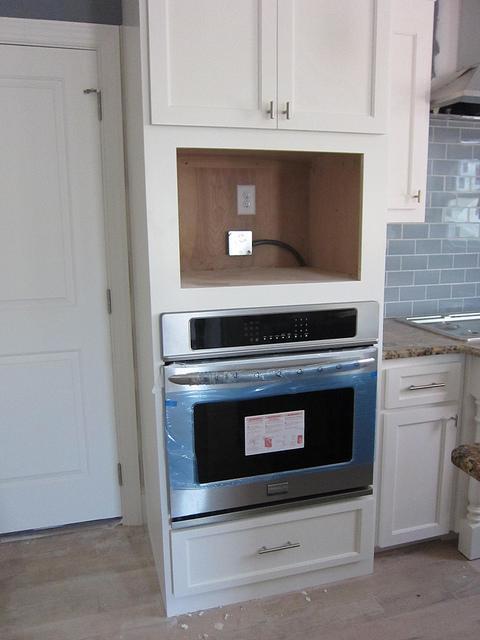How many empty shelves are pictured?
Give a very brief answer. 1. How many brown cows are there on the beach?
Give a very brief answer. 0. 